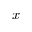<formula> <loc_0><loc_0><loc_500><loc_500>x</formula> 